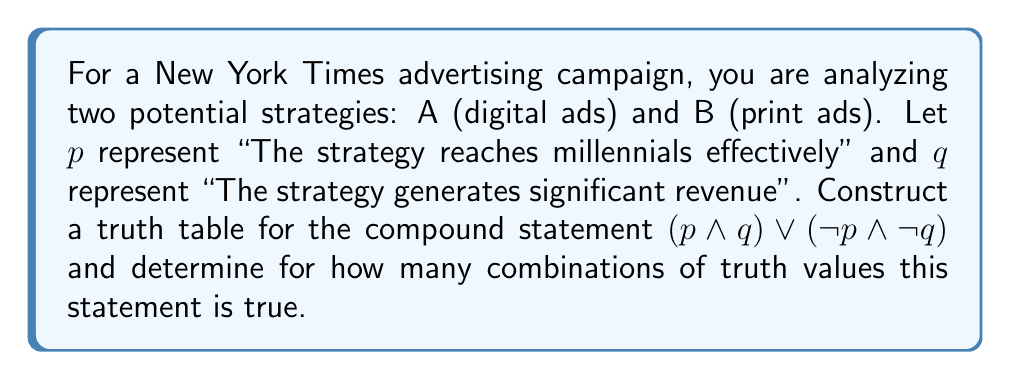Show me your answer to this math problem. Let's approach this step-by-step:

1) First, we need to construct a truth table for the given compound statement:
   $(p \land q) \lor (\neg p \land \neg q)$

2) Our truth table will have 4 rows (2^2 = 4, as we have 2 variables):

   $$
   \begin{array}{|c|c|c|c|c|c|}
   \hline
   p & q & p \land q & \neg p & \neg q & \neg p \land \neg q & (p \land q) \lor (\neg p \land \neg q) \\
   \hline
   T & T & T & F & F & F & T \\
   T & F & F & F & T & F & F \\
   F & T & F & T & F & F & F \\
   F & F & F & T & T & T & T \\
   \hline
   \end{array}
   $$

3) Let's evaluate each column:
   - $p \land q$ is true only when both $p$ and $q$ are true.
   - $\neg p$ is the negation of $p$.
   - $\neg q$ is the negation of $q$.
   - $\neg p \land \neg q$ is true only when both $p$ and $q$ are false.
   - The final column $(p \land q) \lor (\neg p \land \neg q)$ is true when either $p \land q$ or $\neg p \land \neg q$ is true.

4) From the truth table, we can see that the final statement is true in 2 cases:
   - When both $p$ and $q$ are true (first row)
   - When both $p$ and $q$ are false (last row)

Therefore, the compound statement is true for 2 combinations of truth values.
Answer: 2 